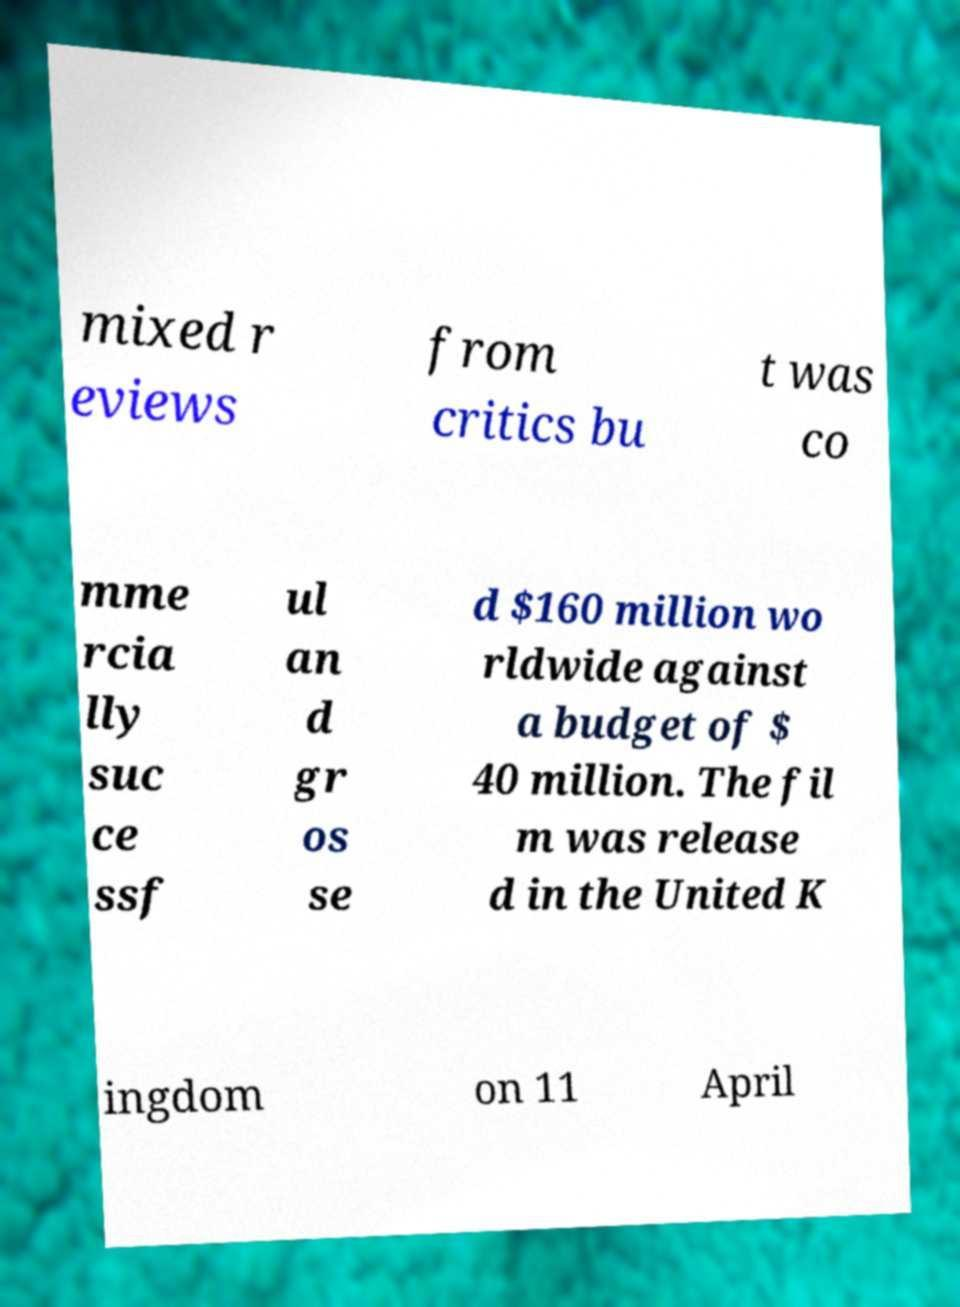Could you extract and type out the text from this image? mixed r eviews from critics bu t was co mme rcia lly suc ce ssf ul an d gr os se d $160 million wo rldwide against a budget of $ 40 million. The fil m was release d in the United K ingdom on 11 April 